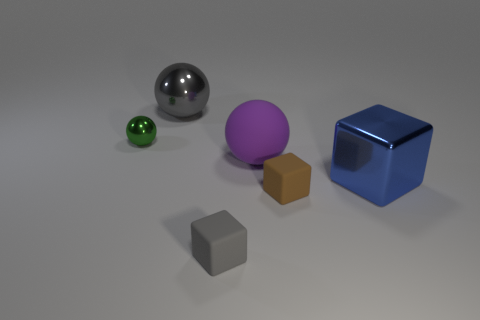Subtract all matte blocks. How many blocks are left? 1 Add 3 big purple spheres. How many objects exist? 9 Subtract all tiny brown rubber things. Subtract all gray objects. How many objects are left? 3 Add 3 rubber spheres. How many rubber spheres are left? 4 Add 6 tiny green objects. How many tiny green objects exist? 7 Subtract 0 cyan cylinders. How many objects are left? 6 